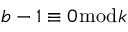Convert formula to latex. <formula><loc_0><loc_0><loc_500><loc_500>b - 1 \equiv 0 { \bmod { k } }</formula> 